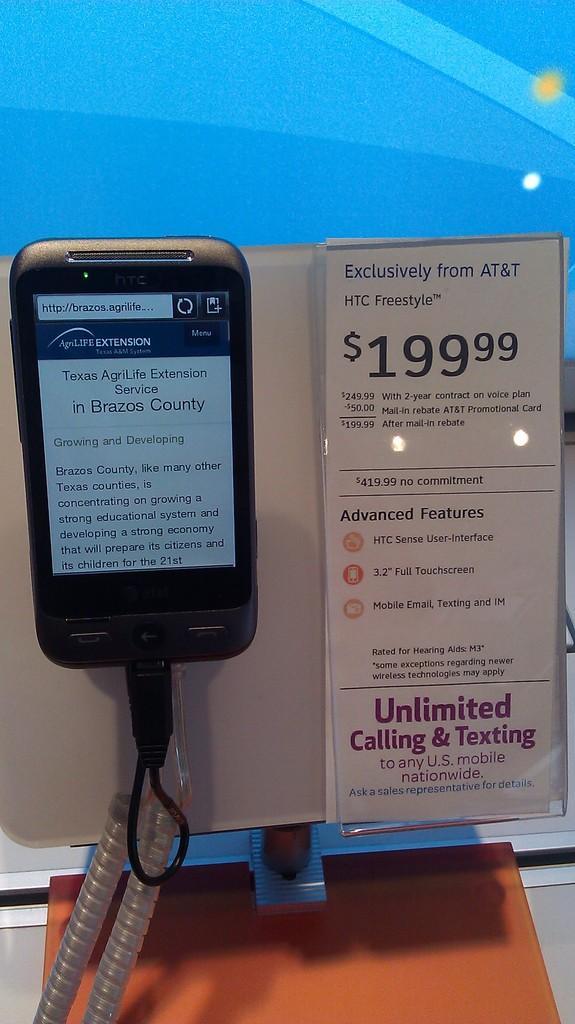Can you describe this image briefly? In this image there is a mobile attached to the price tag, on which there is a text and numbers there is a cable wire visible at the bottom , background color is blue. 